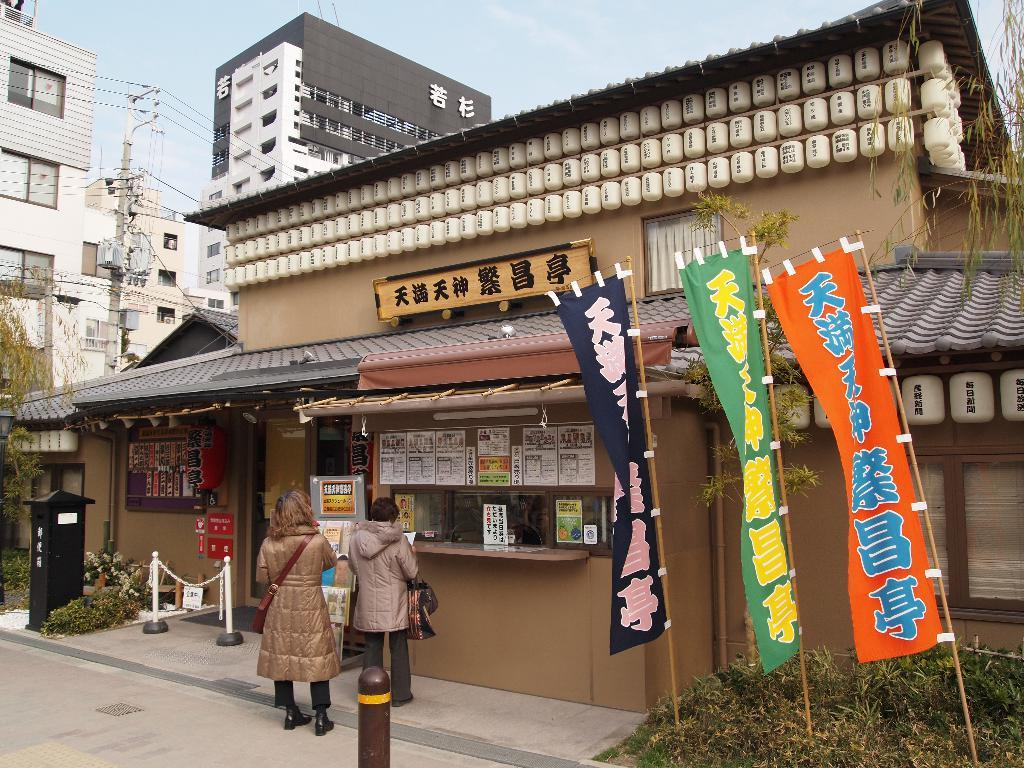How many persons are present in the image? There are two persons standing in the image. What are the persons wearing? Both persons are wearing coats. What type of structure can be seen in the image? There is a store building in the image. What is visible at the top of the image? The sky is visible at the top of the image. What type of coal is being used to cook the celery in the image? There is no coal or celery present in the image. 